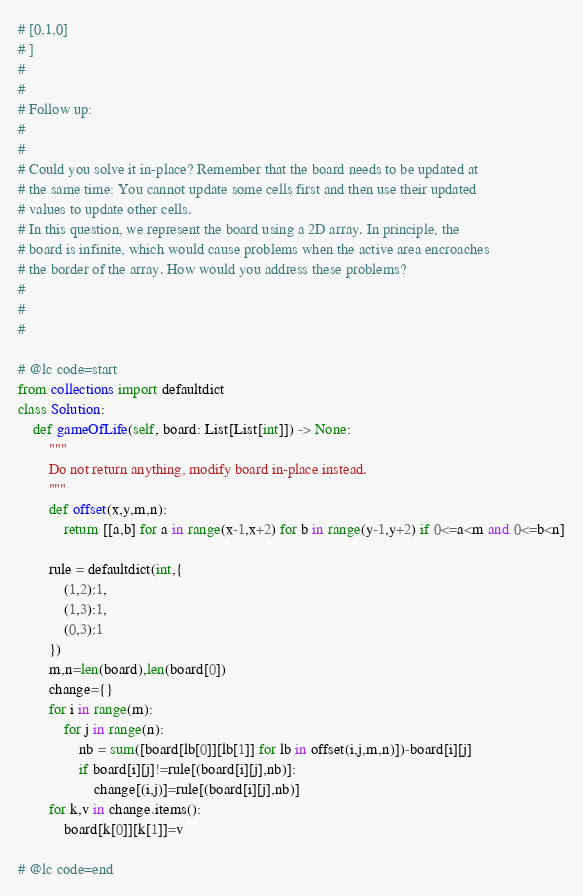Convert code to text. <code><loc_0><loc_0><loc_500><loc_500><_Python_># [0,1,0]
# ]
# 
# 
# Follow up:
# 
# 
# Could you solve it in-place? Remember that the board needs to be updated at
# the same time: You cannot update some cells first and then use their updated
# values to update other cells.
# In this question, we represent the board using a 2D array. In principle, the
# board is infinite, which would cause problems when the active area encroaches
# the border of the array. How would you address these problems?
# 
# 
#

# @lc code=start
from collections import defaultdict
class Solution:
    def gameOfLife(self, board: List[List[int]]) -> None:
        """
        Do not return anything, modify board in-place instead.
        """
        def offset(x,y,m,n):
            return [[a,b] for a in range(x-1,x+2) for b in range(y-1,y+2) if 0<=a<m and 0<=b<n]
        
        rule = defaultdict(int,{
            (1,2):1,
            (1,3):1,
            (0,3):1
        })
        m,n=len(board),len(board[0])
        change={}
        for i in range(m):
            for j in range(n):
                nb = sum([board[lb[0]][lb[1]] for lb in offset(i,j,m,n)])-board[i][j]
                if board[i][j]!=rule[(board[i][j],nb)]:
                    change[(i,j)]=rule[(board[i][j],nb)]
        for k,v in change.items():
            board[k[0]][k[1]]=v

# @lc code=end

</code> 